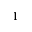Convert formula to latex. <formula><loc_0><loc_0><loc_500><loc_500>^ { 1 }</formula> 